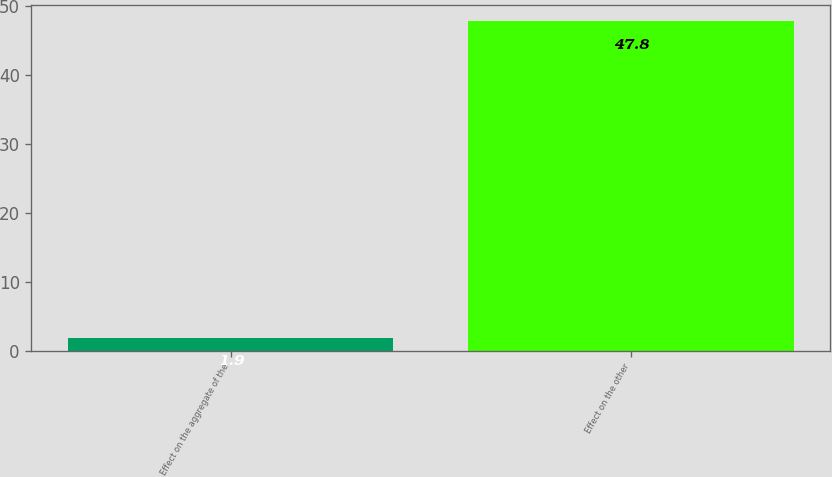Convert chart. <chart><loc_0><loc_0><loc_500><loc_500><bar_chart><fcel>Effect on the aggregate of the<fcel>Effect on the other<nl><fcel>1.9<fcel>47.8<nl></chart> 